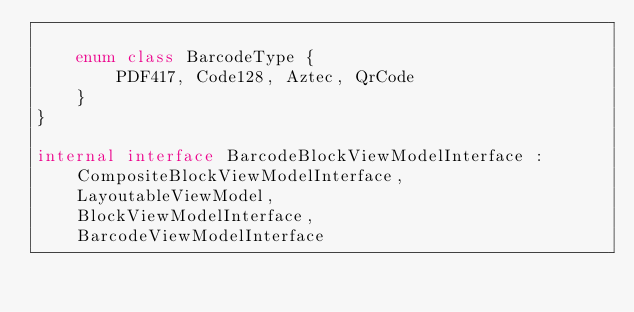<code> <loc_0><loc_0><loc_500><loc_500><_Kotlin_>
    enum class BarcodeType {
        PDF417, Code128, Aztec, QrCode
    }
}

internal interface BarcodeBlockViewModelInterface :
    CompositeBlockViewModelInterface,
    LayoutableViewModel,
    BlockViewModelInterface,
    BarcodeViewModelInterface</code> 